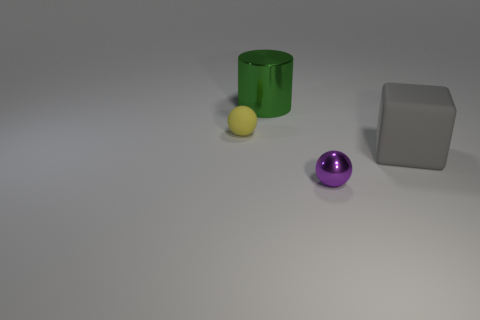There is a yellow ball; is it the same size as the matte object that is right of the small yellow thing?
Give a very brief answer. No. What number of blocks are large metallic things or tiny objects?
Your response must be concise. 0. What number of objects are both left of the gray rubber object and behind the tiny purple thing?
Provide a short and direct response. 2. There is a tiny object behind the gray thing; what shape is it?
Provide a succinct answer. Sphere. Is the material of the large gray cube the same as the purple thing?
Your answer should be compact. No. Is there any other thing that has the same size as the yellow matte object?
Your answer should be compact. Yes. How many large things are on the left side of the large cube?
Provide a short and direct response. 1. What is the shape of the thing that is behind the matte object left of the green shiny thing?
Offer a terse response. Cylinder. Is there any other thing that is the same shape as the green metallic thing?
Your answer should be very brief. No. Are there more metallic spheres in front of the tiny purple metallic object than green metal objects?
Your answer should be compact. No. 